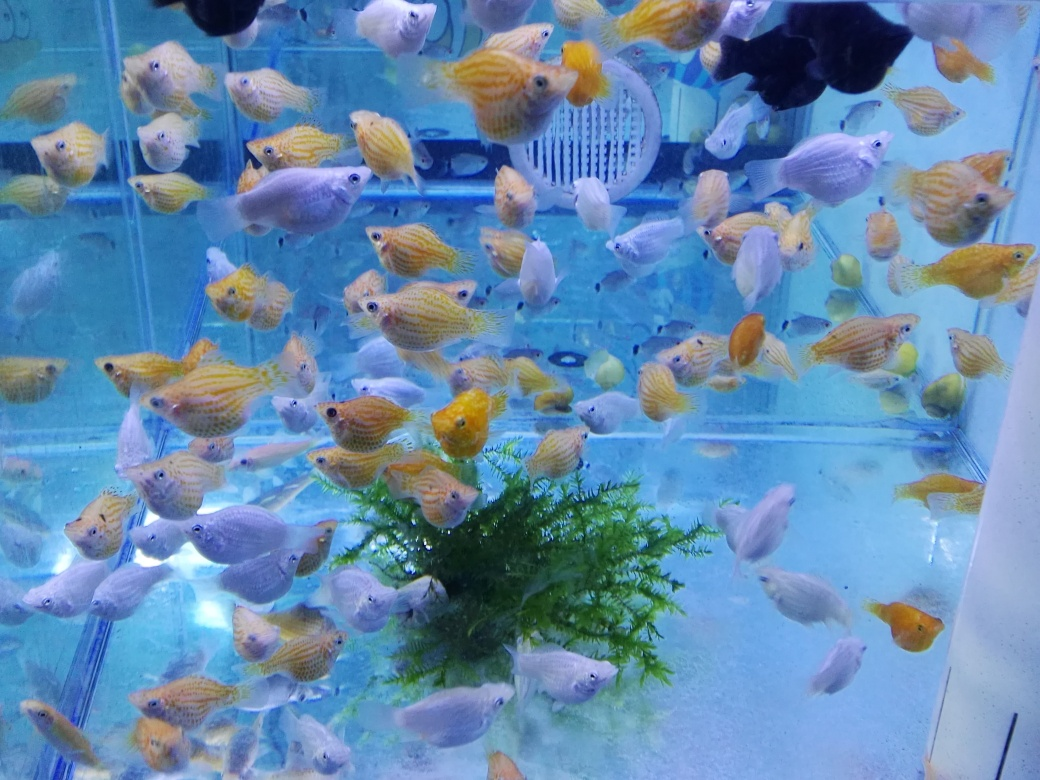What might be the purpose of keeping an aquarium like this one? An aquarium of this type could serve multiple purposes: for hobbyists, it's a relaxing and fulfilling pastime to cultivate and observe an aquatic ecosystem; for educational settings, it could be a live example to study marine biology; and commercially, it could be an attractive display in a pet store or public space. 